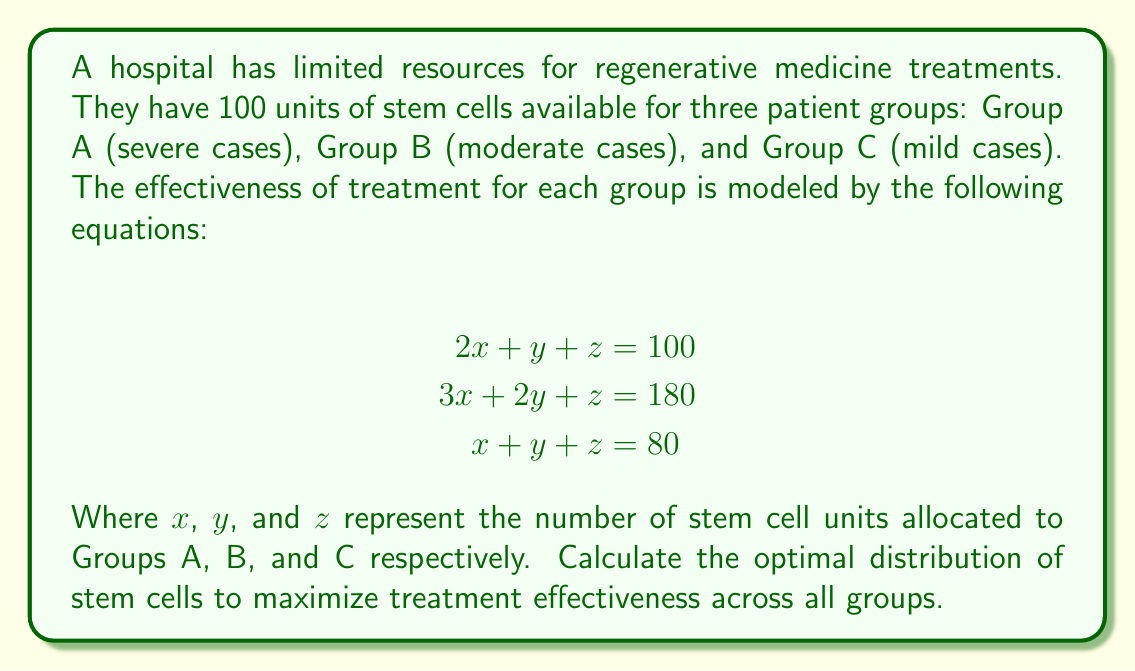Show me your answer to this math problem. To solve this system of equations, we'll use the elimination method:

1) First, subtract the third equation from the first:
   $$ (2x + y + z) - (x + y + z) = 100 - 80 $$
   $$ x = 20 $$

2) Now, subtract the third equation from the second:
   $$ (3x + 2y + z) - (x + y + z) = 180 - 80 $$
   $$ 2x + y = 100 $$

3) Substitute $x = 20$ into this equation:
   $$ 2(20) + y = 100 $$
   $$ 40 + y = 100 $$
   $$ y = 60 $$

4) Now that we have $x$ and $y$, we can substitute these into the third equation to find $z$:
   $$ x + y + z = 80 $$
   $$ 20 + 60 + z = 80 $$
   $$ z = 0 $$

5) Check the solution in all three original equations to verify:
   $$ \begin{align}
   2(20) + 60 + 0 &= 100 \\
   3(20) + 2(60) + 0 &= 180 \\
   20 + 60 + 0 &= 80
   \end{align} $$

   All equations are satisfied, confirming our solution.

The optimal distribution is:
Group A (severe cases): 20 units
Group B (moderate cases): 60 units
Group C (mild cases): 0 units

This distribution maximizes the effectiveness of the treatment across all groups given the constraints of the model.
Answer: $x = 20$, $y = 60$, $z = 0$ 